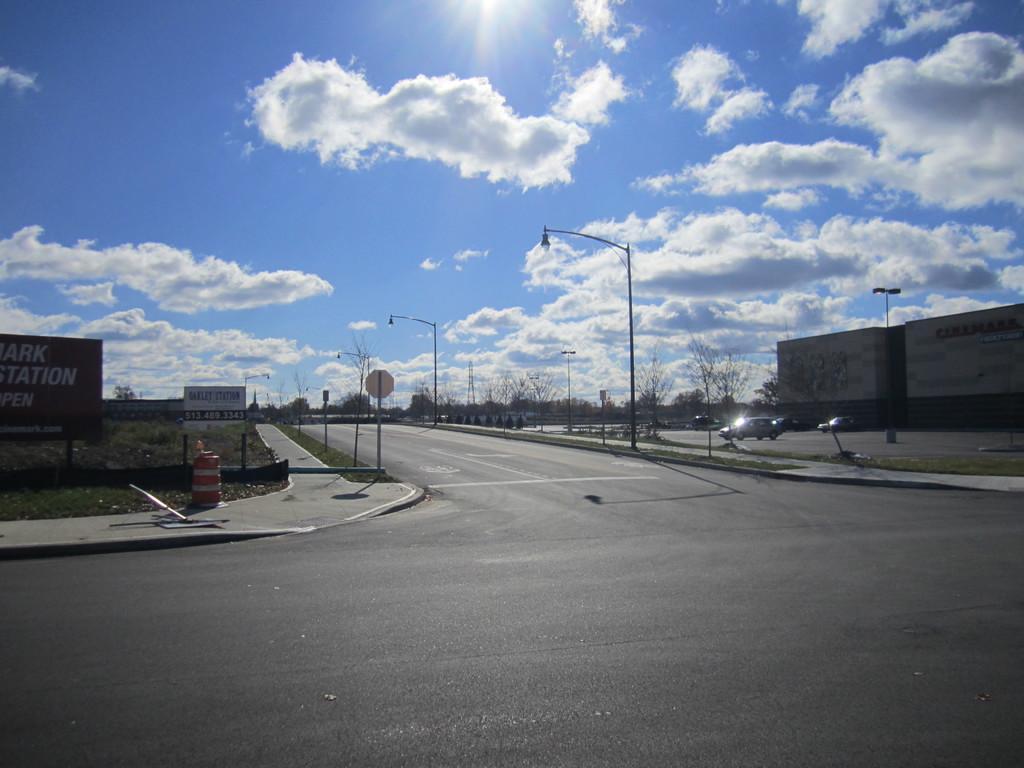Can you describe this image briefly? In the middle of the image there are some poles, sign boards, banners and vehicles on the road. Behind them there are some trees and buildings. At the top of the image there are some clouds in the sky. 